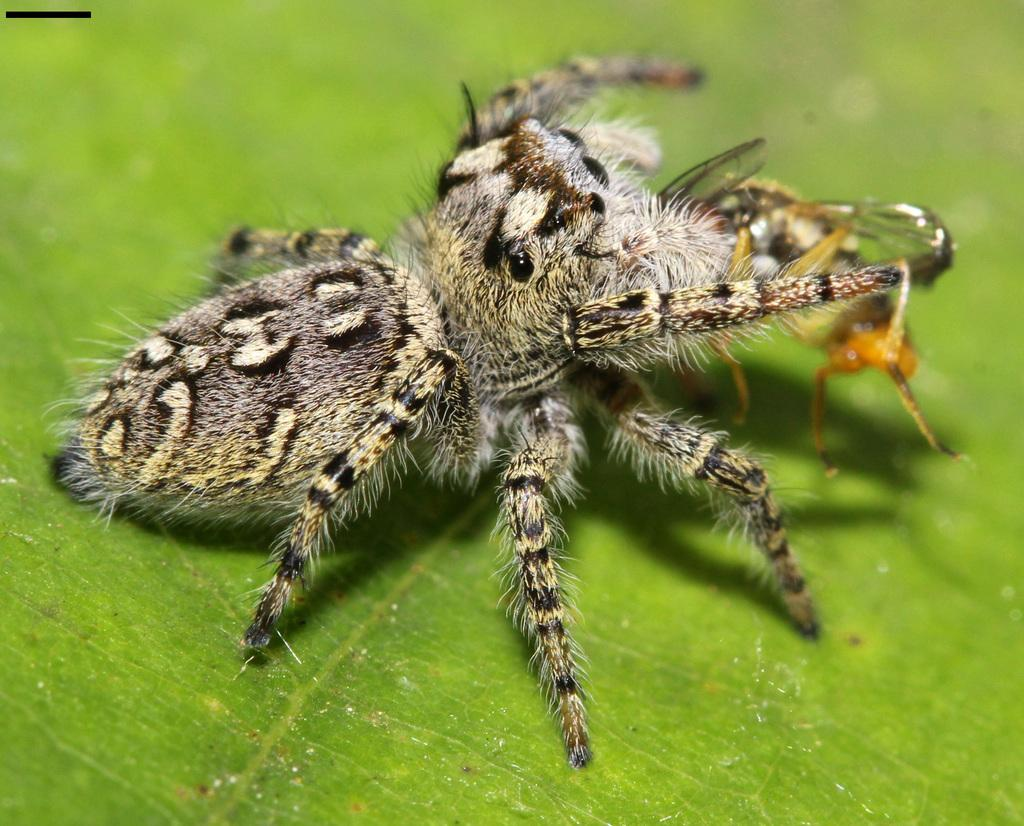What is the main subject of the image? The main subject of the image is a spider. Where is the spider located in the image? The spider is standing on a leaf. What is the weight of the spider in the image? The weight of the spider cannot be determined from the image alone, as it is not possible to accurately measure the weight of a spider based on a photograph. 